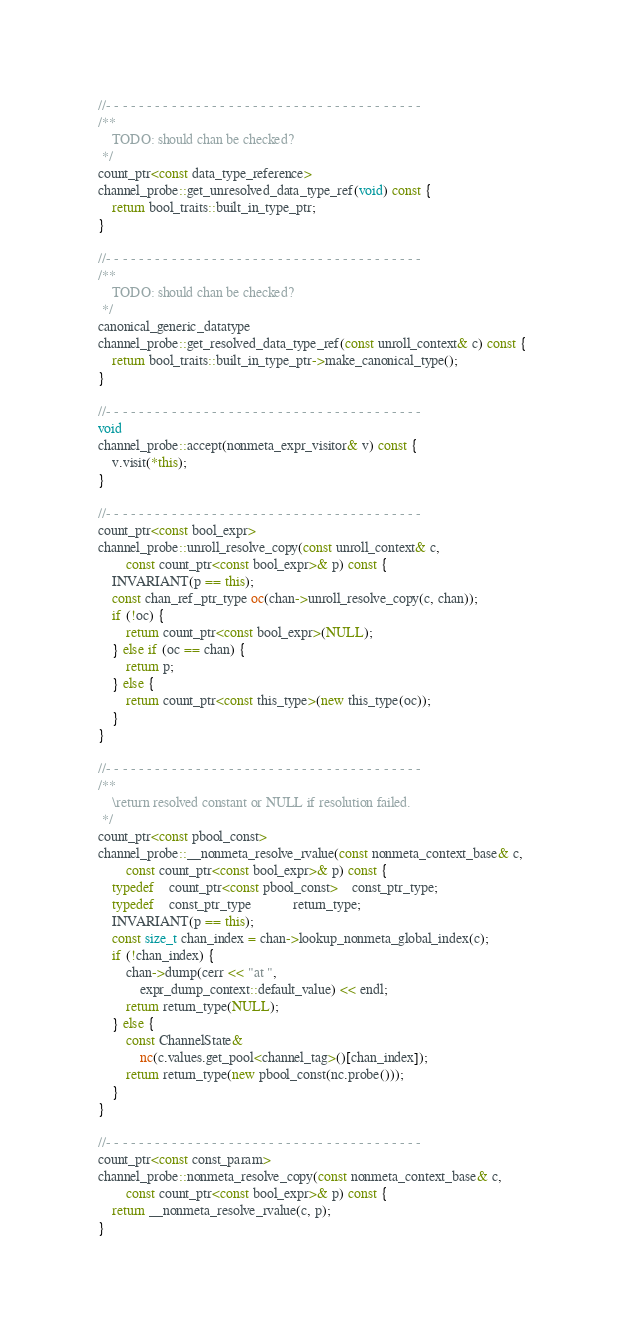Convert code to text. <code><loc_0><loc_0><loc_500><loc_500><_C++_>
//- - - - - - - - - - - - - - - - - - - - - - - - - - - - - - - - - - - - - - -
/**
	TODO: should chan be checked?
 */
count_ptr<const data_type_reference>
channel_probe::get_unresolved_data_type_ref(void) const {
	return bool_traits::built_in_type_ptr;
}

//- - - - - - - - - - - - - - - - - - - - - - - - - - - - - - - - - - - - - - -
/**
	TODO: should chan be checked?
 */
canonical_generic_datatype
channel_probe::get_resolved_data_type_ref(const unroll_context& c) const {
	return bool_traits::built_in_type_ptr->make_canonical_type();
}

//- - - - - - - - - - - - - - - - - - - - - - - - - - - - - - - - - - - - - - -
void
channel_probe::accept(nonmeta_expr_visitor& v) const {
	v.visit(*this);
}

//- - - - - - - - - - - - - - - - - - - - - - - - - - - - - - - - - - - - - - -
count_ptr<const bool_expr>
channel_probe::unroll_resolve_copy(const unroll_context& c, 
		const count_ptr<const bool_expr>& p) const {
	INVARIANT(p == this);
	const chan_ref_ptr_type oc(chan->unroll_resolve_copy(c, chan));
	if (!oc) {
		return count_ptr<const bool_expr>(NULL);
	} else if (oc == chan) {
		return p;
	} else {
		return count_ptr<const this_type>(new this_type(oc));
	}
}

//- - - - - - - - - - - - - - - - - - - - - - - - - - - - - - - - - - - - - - -
/**
	\return resolved constant or NULL if resolution failed.  
 */
count_ptr<const pbool_const>
channel_probe::__nonmeta_resolve_rvalue(const nonmeta_context_base& c, 
		const count_ptr<const bool_expr>& p) const {
	typedef	count_ptr<const pbool_const>	const_ptr_type;
	typedef	const_ptr_type			return_type;
	INVARIANT(p == this);
	const size_t chan_index = chan->lookup_nonmeta_global_index(c);
	if (!chan_index) {
		chan->dump(cerr << "at ",
			expr_dump_context::default_value) << endl;
		return return_type(NULL);
	} else {
		const ChannelState&
			nc(c.values.get_pool<channel_tag>()[chan_index]);
		return return_type(new pbool_const(nc.probe()));
	}
}

//- - - - - - - - - - - - - - - - - - - - - - - - - - - - - - - - - - - - - - -
count_ptr<const const_param>
channel_probe::nonmeta_resolve_copy(const nonmeta_context_base& c, 
		const count_ptr<const bool_expr>& p) const {
	return __nonmeta_resolve_rvalue(c, p);
}
</code> 